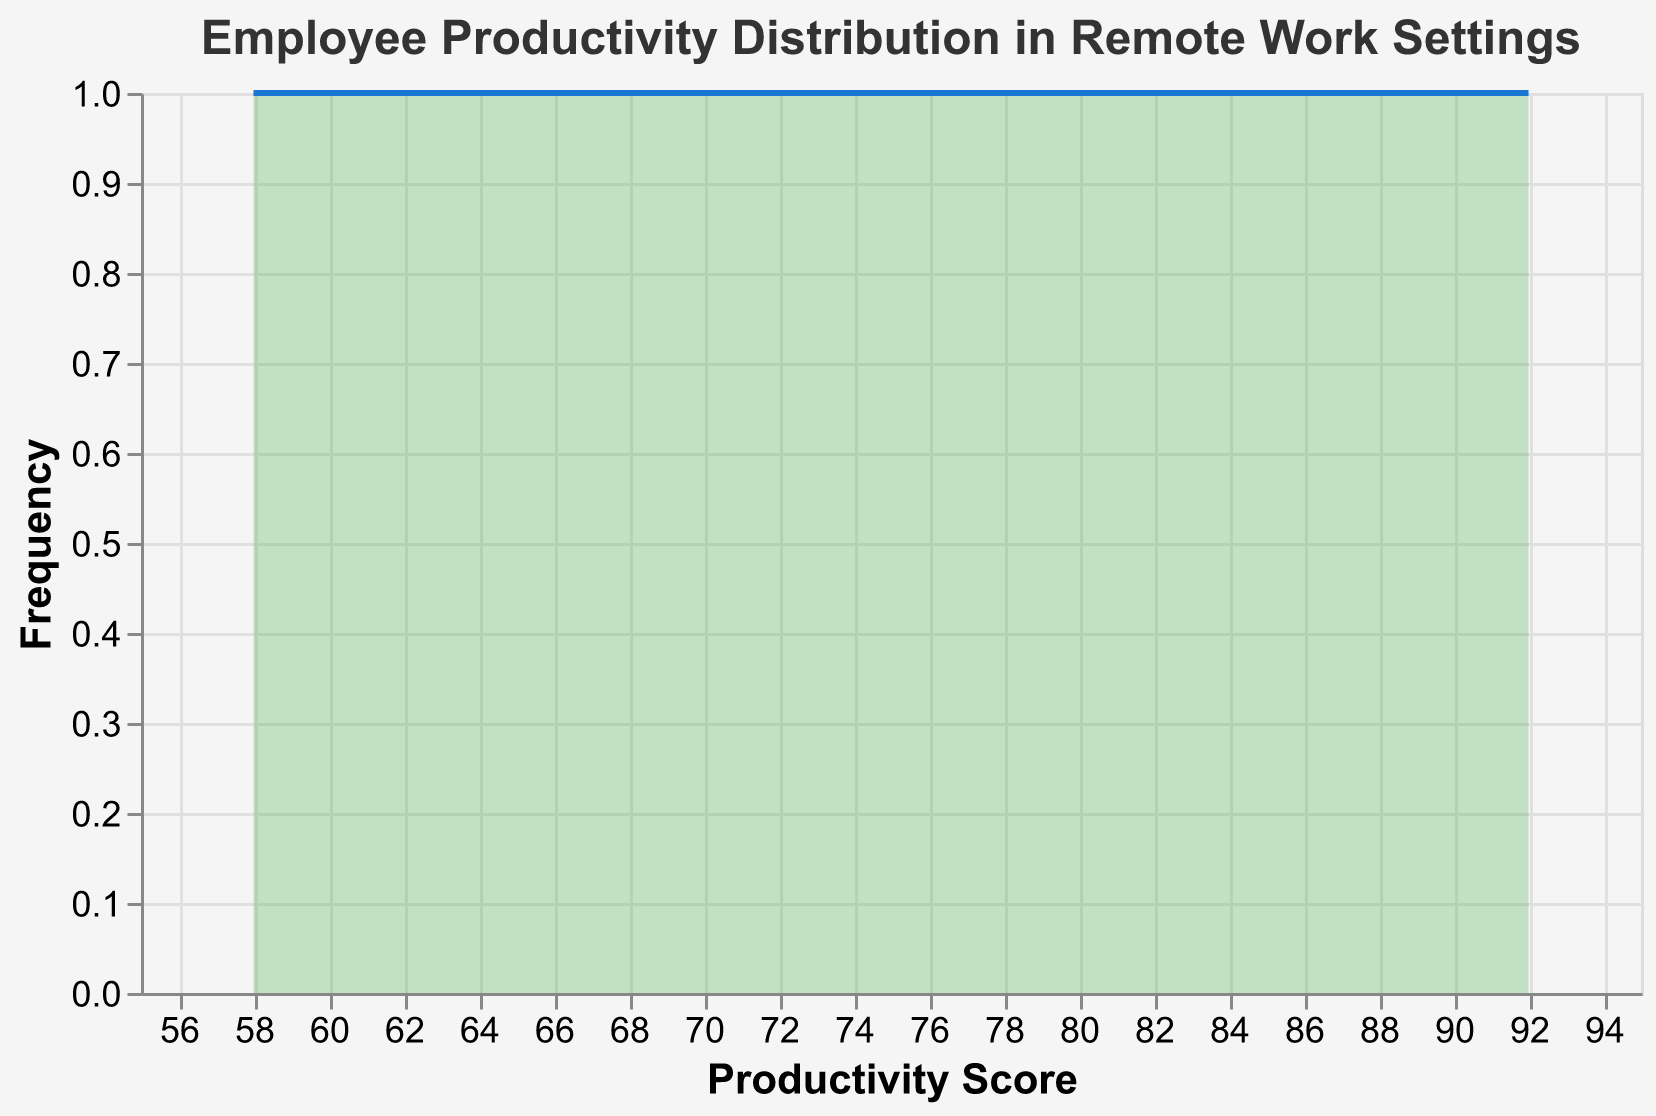What is the title of the figure? The title is usually displayed at the top of the figure and is meant to give a quick indication of what the chart is about.
Answer: Employee Productivity Distribution in Remote Work Settings What are the axes titles? The axes titles are usually displayed alongside the axes to indicate what each axis represents. In this chart, the x-axis title reads "Productivity Score," and the y-axis title reads "Frequency."
Answer: Productivity Score and Frequency What is the range of the Productivity Scores shown in the figure? To determine the range of the Productivity Scores, look at the minimum and maximum values on the x-axis.
Answer: 58 to 92 How many employees are represented in the dataset? Counting the number of data points will give the number of employees. Based on the provided data, there are 20 employees (from EmployeeID E001 to E020).
Answer: 20 What color is used for the area mark in the figure? The area mark, which represents the distribution, is filled with a light green color.
Answer: Light green (#4CAF50) What is the shape of the distribution of Productivity Scores in the figure? By observing the area mark and the line mark, we can see that the distribution of Productivity Scores forms a roughly bell-shaped or normal distribution.
Answer: Bell-shaped How frequently do Productivity Scores appear around the value of 80? To address this, observe the height of the distribution around the x-axis value of 80. The frequency can be approximated by the height of the curve at that point.
Answer: Most frequent (highest peak) Is there a higher concentration of employees with lower Productivity Scores or higher Productivity Scores? The concentration can be determined by examining whether the distribution is skewed towards the lower or higher end of the x-axis. Given the bell shape, the concentration seems to be slightly higher in the range of higher Productivity Scores.
Answer: Higher Productivity Scores Considering the widths of the peaks, is the distribution more spread out or clustered tightly around certain values? Determine if the distribution is tight or spread out by the width and spread of the peaks in the area plot and line. A wider peak indicates a more spread out distribution, whereas narrower peaks indicate a tighter clustering.
Answer: More spread out Which score marks the center of the distribution, and is this the same as the highest frequency score? The center of the distribution can be identified as the point where the bell of the curve is highest. This is also typically the point with the highest frequency.
Answer: Around 80 